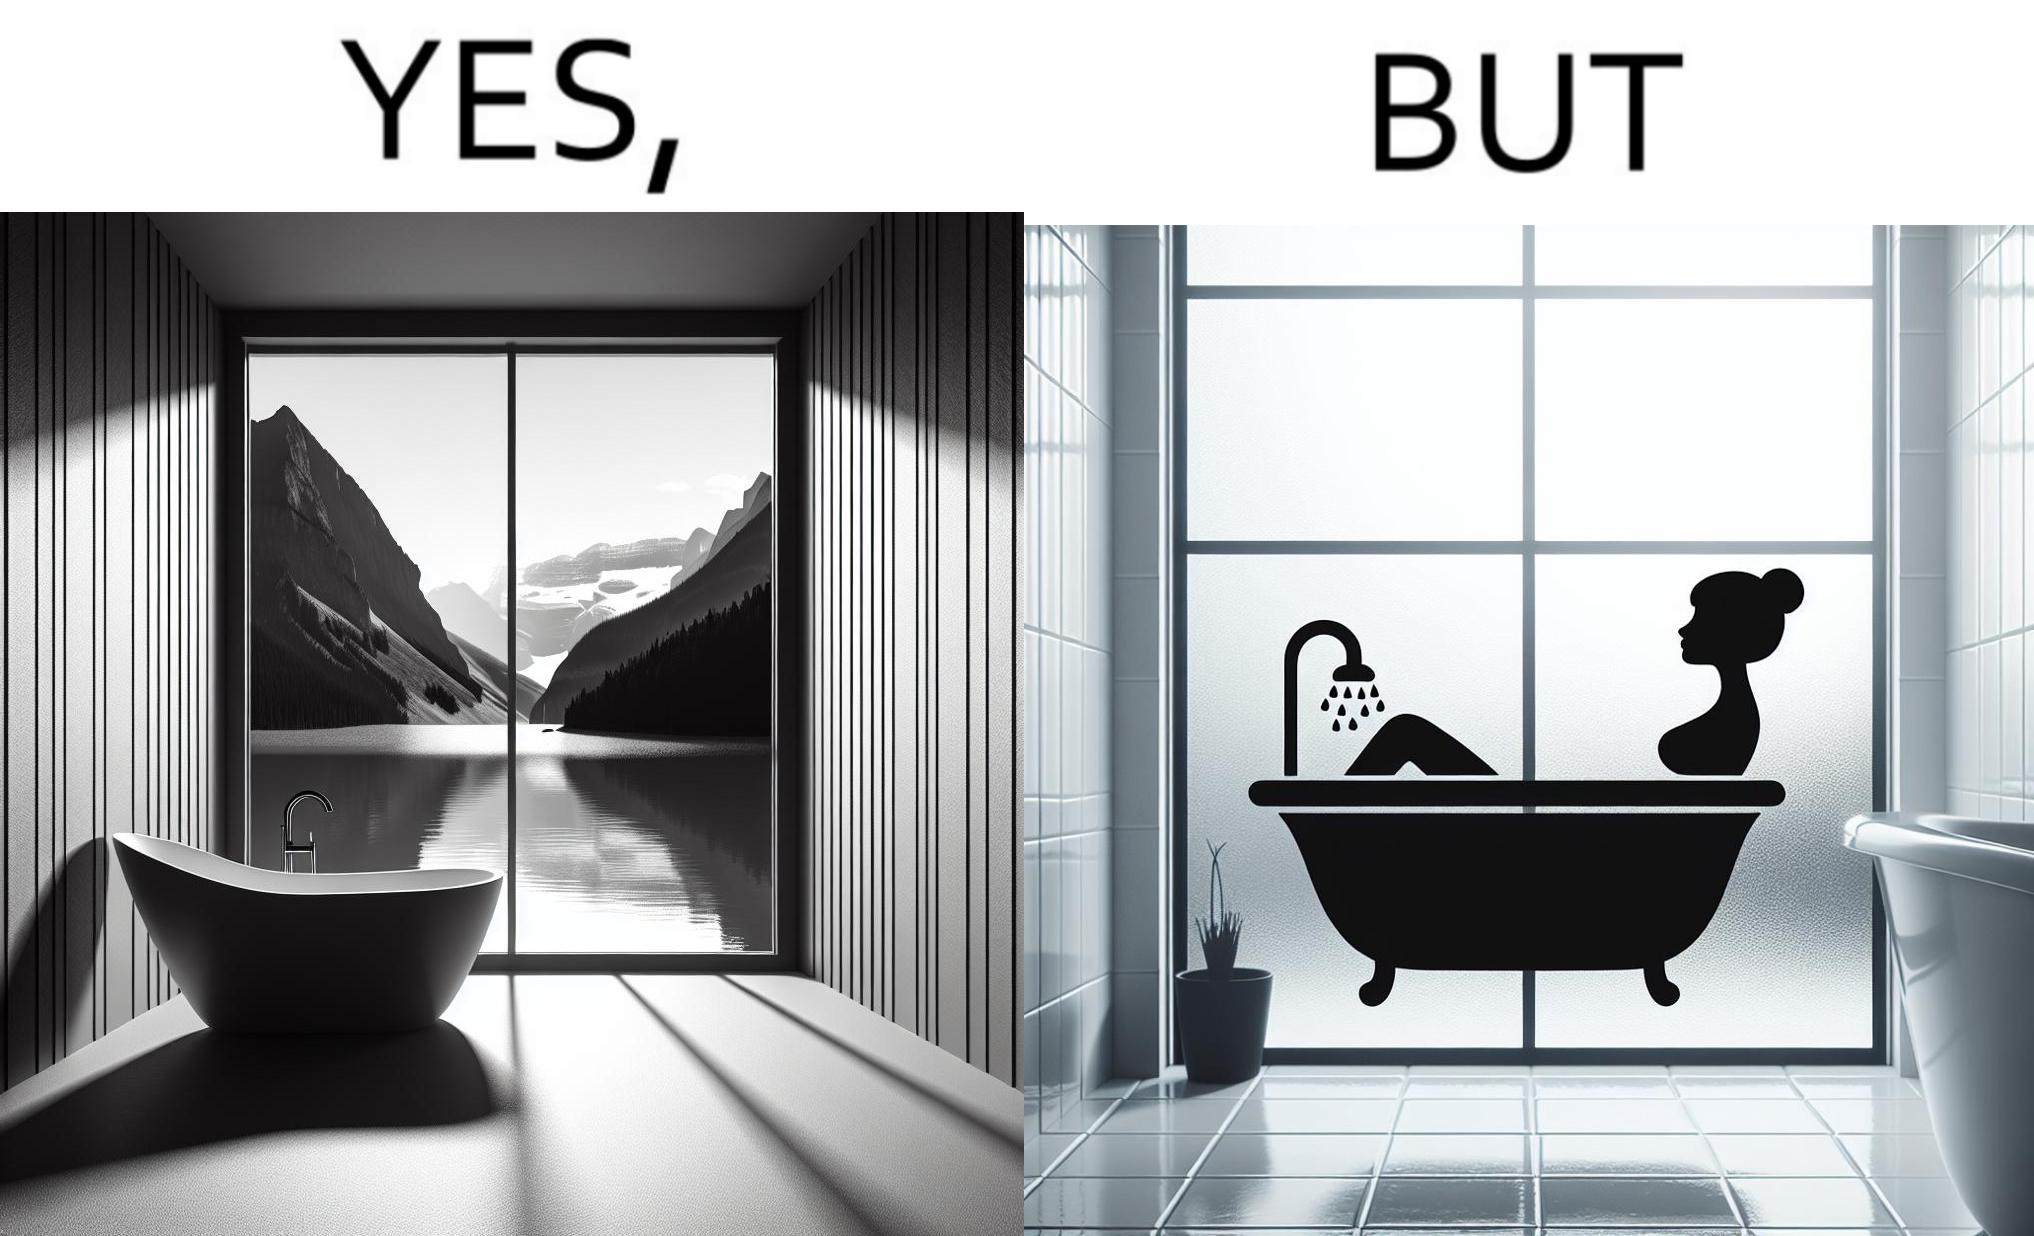What is the satirical meaning behind this image? The image is ironical, as a bathtub near a window having a very scenic view, becomes misty when someone is bathing, thus making the scenic view blurry. 